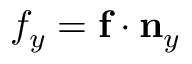<formula> <loc_0><loc_0><loc_500><loc_500>{ f } _ { y } = f \cdot n _ { y }</formula> 